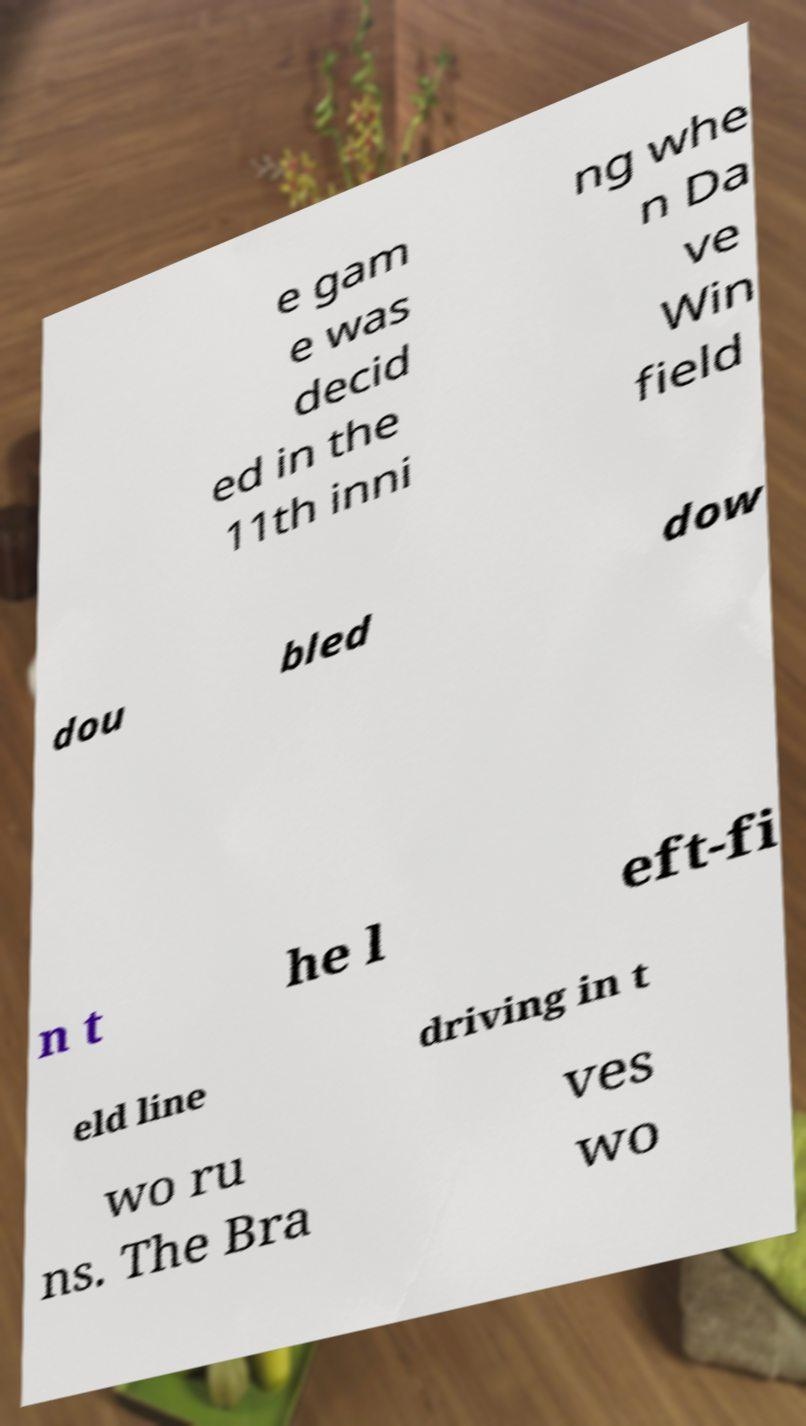Could you assist in decoding the text presented in this image and type it out clearly? e gam e was decid ed in the 11th inni ng whe n Da ve Win field dou bled dow n t he l eft-fi eld line driving in t wo ru ns. The Bra ves wo 